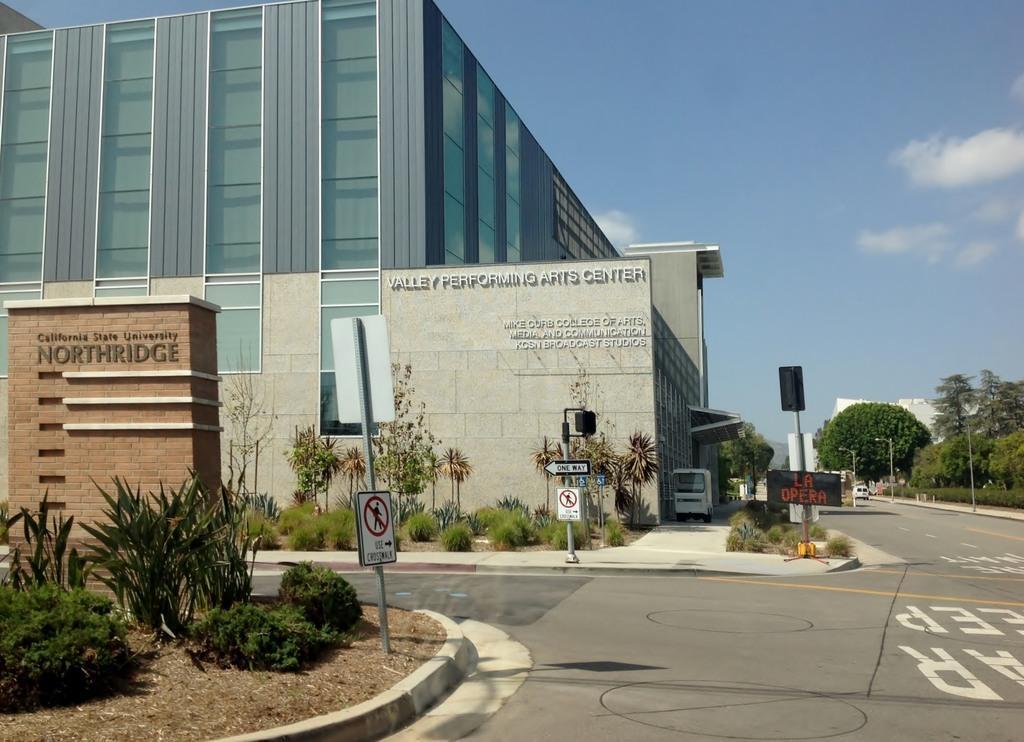How would you summarize this image in a sentence or two? In this image there is a road. There are plants and grass. There is sand. We can see buildings. There is text on the walls. There are trees. There is sky. 